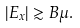<formula> <loc_0><loc_0><loc_500><loc_500>| E _ { x } | \gtrsim B \mu .</formula> 